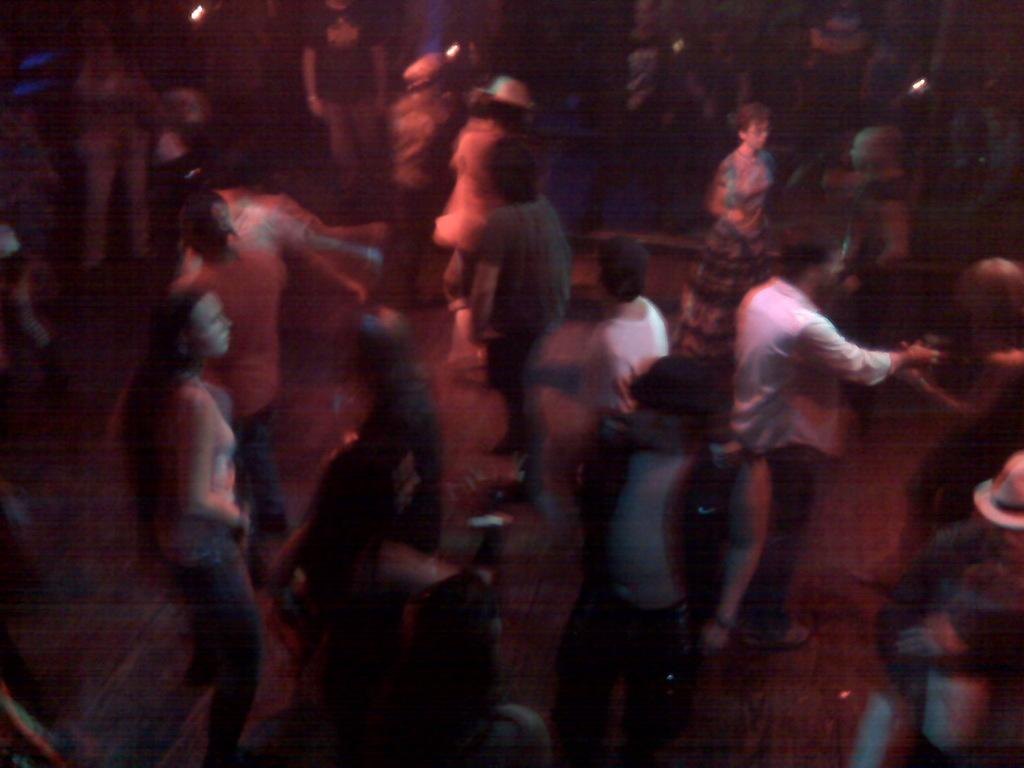How many people are in the image? There are persons standing in the image. What can be observed on the persons in the image? There is a red color light on the persons. Are there any women in the image? The provided facts do not specify the gender of the persons in the image, so it cannot be determined from the information given. 